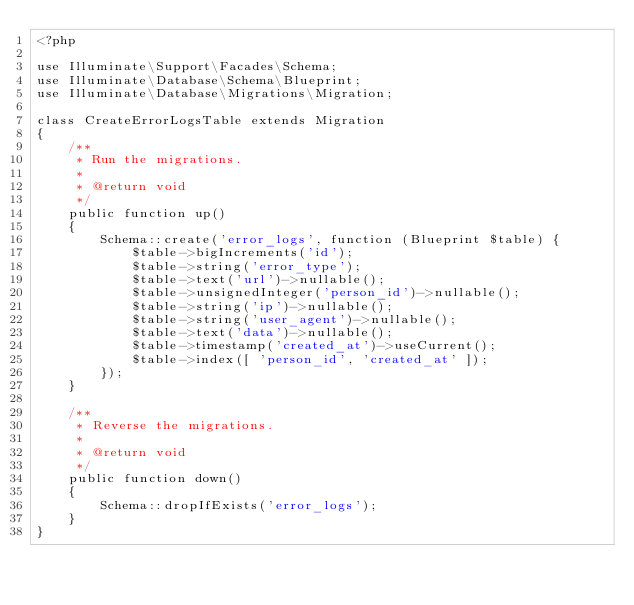<code> <loc_0><loc_0><loc_500><loc_500><_PHP_><?php

use Illuminate\Support\Facades\Schema;
use Illuminate\Database\Schema\Blueprint;
use Illuminate\Database\Migrations\Migration;

class CreateErrorLogsTable extends Migration
{
    /**
     * Run the migrations.
     *
     * @return void
     */
    public function up()
    {
        Schema::create('error_logs', function (Blueprint $table) {
            $table->bigIncrements('id');
            $table->string('error_type');
            $table->text('url')->nullable();
            $table->unsignedInteger('person_id')->nullable();
            $table->string('ip')->nullable();
            $table->string('user_agent')->nullable();
            $table->text('data')->nullable();
            $table->timestamp('created_at')->useCurrent();
            $table->index([ 'person_id', 'created_at' ]);
        });
    }

    /**
     * Reverse the migrations.
     *
     * @return void
     */
    public function down()
    {
        Schema::dropIfExists('error_logs');
    }
}
</code> 